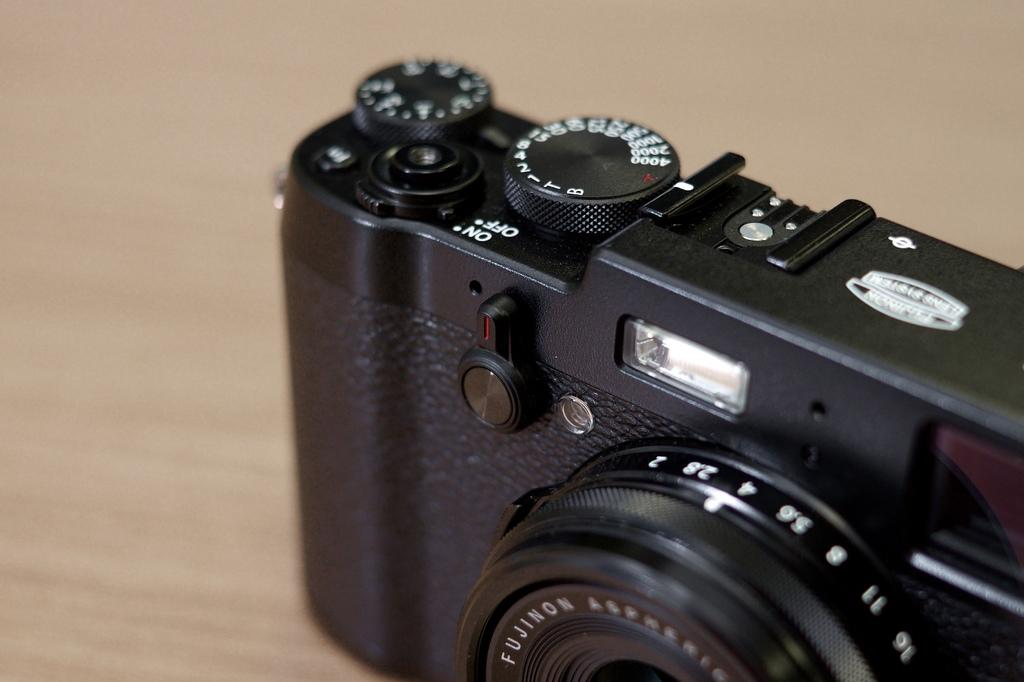<image>
Render a clear and concise summary of the photo. A thirty five mm camera facing the left, the switch on top is turned to on. 